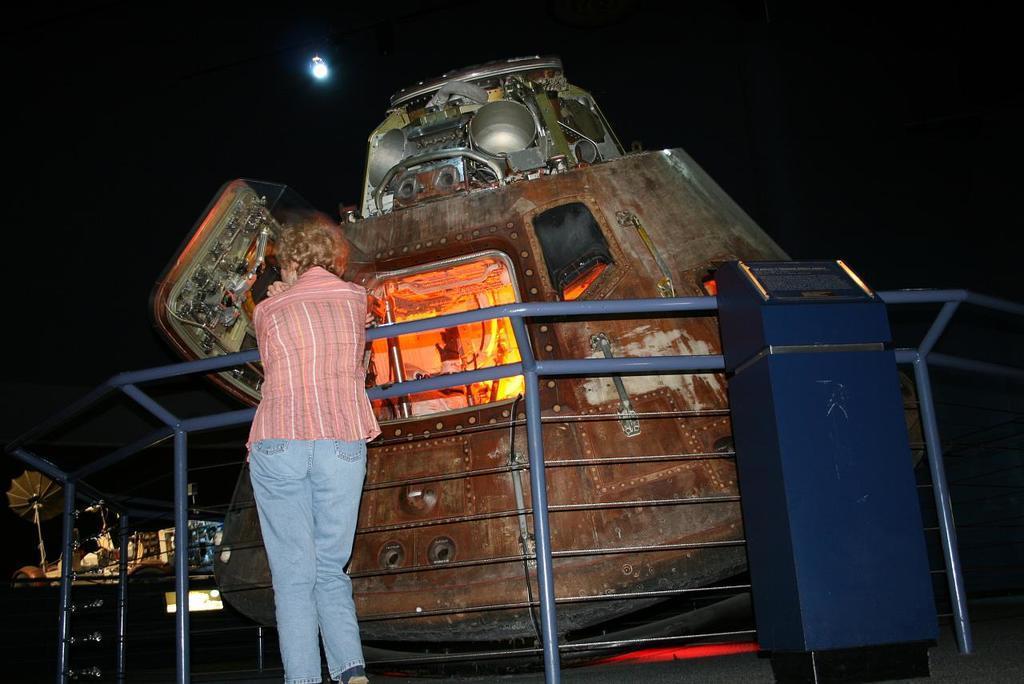Describe this image in one or two sentences. There is one woman standing as we can see on the left side of this image, and there is a metal object present in the middle of this image. 